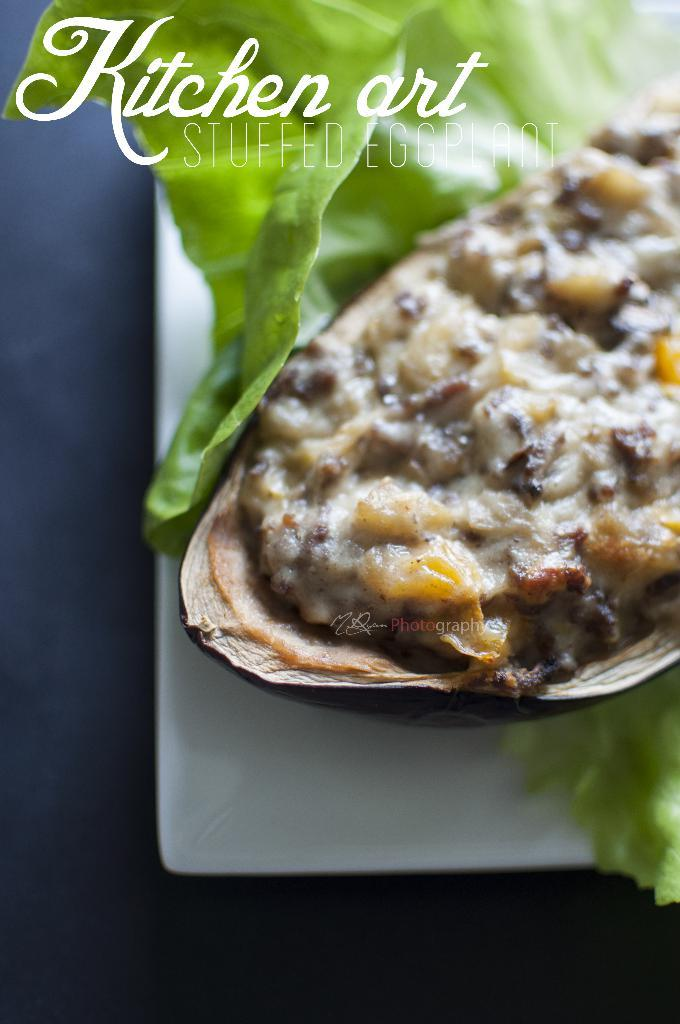What is on the plate in the image? There is food on a plate in the image. Can you describe any additional features of the image? A watermark is visible on the image. How many sticks are present in the image? There is no mention of sticks in the image, so we cannot determine their presence or quantity. 